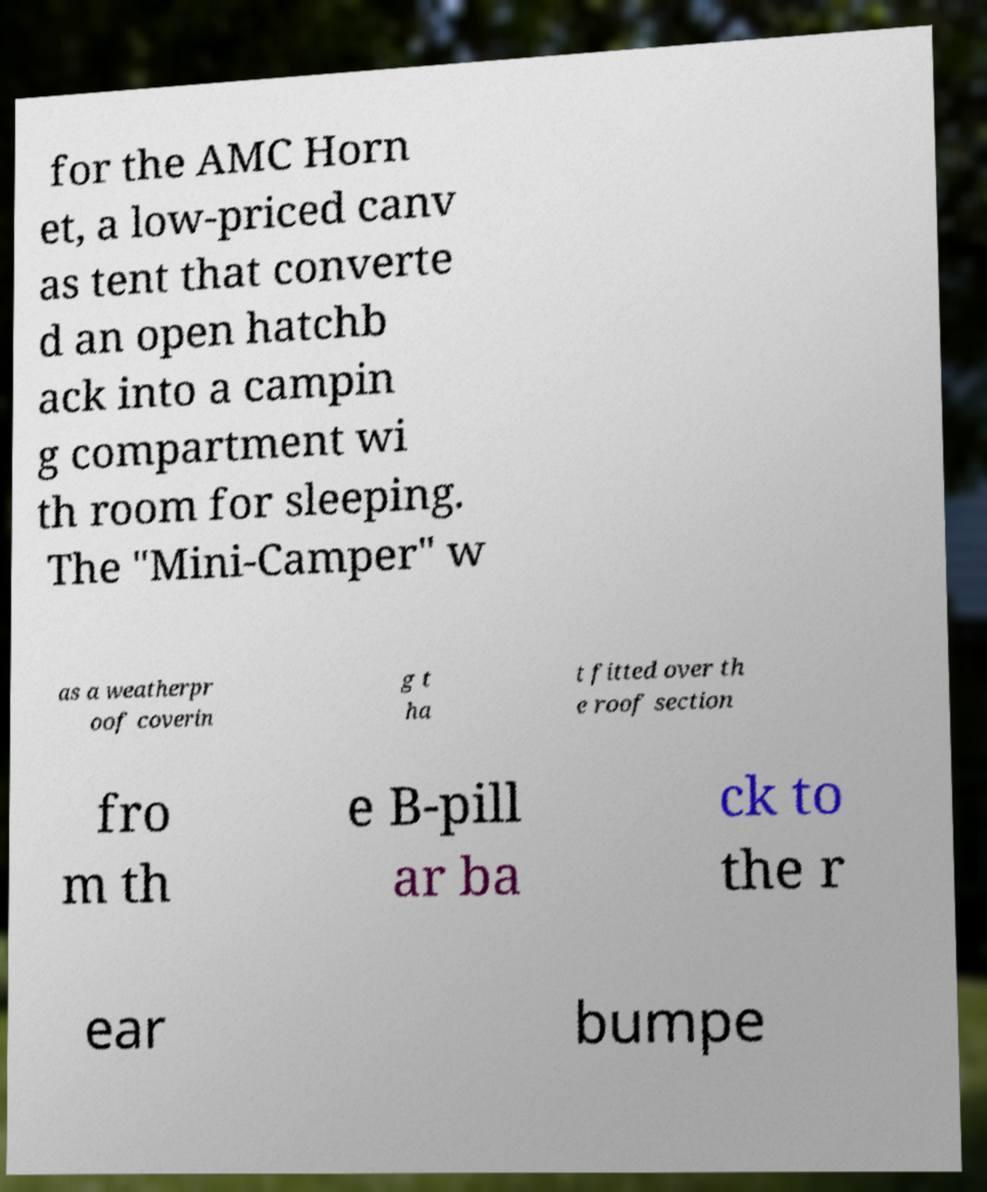Can you accurately transcribe the text from the provided image for me? for the AMC Horn et, a low-priced canv as tent that converte d an open hatchb ack into a campin g compartment wi th room for sleeping. The "Mini-Camper" w as a weatherpr oof coverin g t ha t fitted over th e roof section fro m th e B-pill ar ba ck to the r ear bumpe 